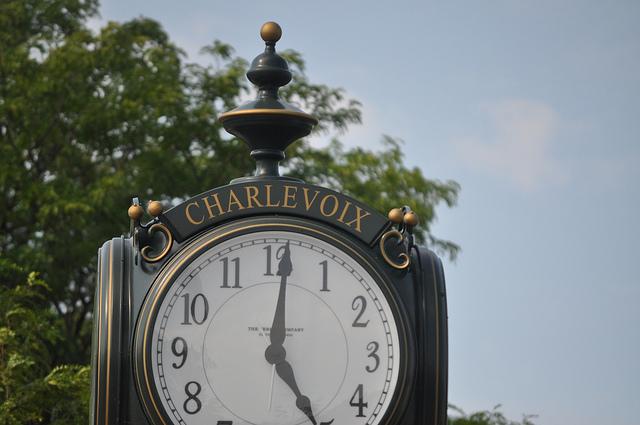What time is it?
Write a very short answer. 5:01. What is the name above the clock face?
Concise answer only. Charlevoix. What time is it here?
Answer briefly. 5:01. What color is the ornament?
Be succinct. Black. What type of numerals are used on the clock?
Be succinct. Numerical. What time is shown on the clock?
Short answer required. 5:01. Is the clock number Roman numeral?
Write a very short answer. No. What time does the clock read?
Keep it brief. 5. Is this a Hightower?
Be succinct. No. What language is on the clock?
Write a very short answer. French. What design is on the clock?
Keep it brief. Modern. 